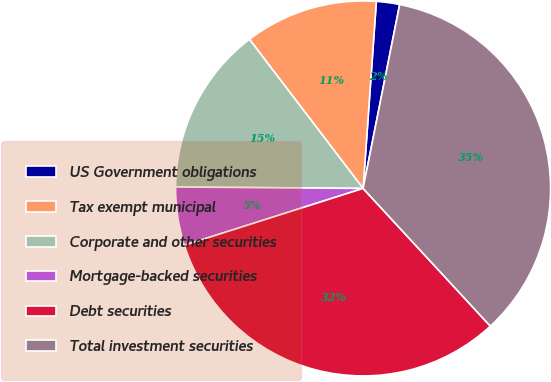Convert chart. <chart><loc_0><loc_0><loc_500><loc_500><pie_chart><fcel>US Government obligations<fcel>Tax exempt municipal<fcel>Corporate and other securities<fcel>Mortgage-backed securities<fcel>Debt securities<fcel>Total investment securities<nl><fcel>2.0%<fcel>11.49%<fcel>14.51%<fcel>5.02%<fcel>31.97%<fcel>35.0%<nl></chart> 